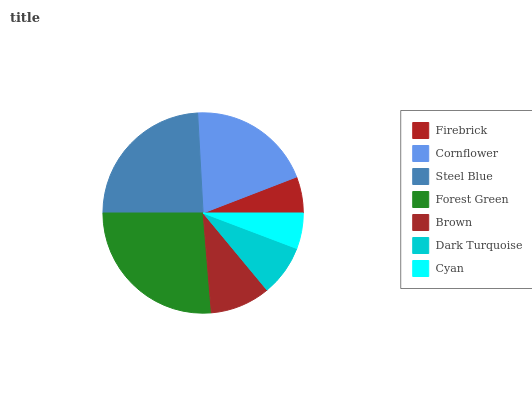Is Cyan the minimum?
Answer yes or no. Yes. Is Forest Green the maximum?
Answer yes or no. Yes. Is Cornflower the minimum?
Answer yes or no. No. Is Cornflower the maximum?
Answer yes or no. No. Is Cornflower greater than Firebrick?
Answer yes or no. Yes. Is Firebrick less than Cornflower?
Answer yes or no. Yes. Is Firebrick greater than Cornflower?
Answer yes or no. No. Is Cornflower less than Firebrick?
Answer yes or no. No. Is Brown the high median?
Answer yes or no. Yes. Is Brown the low median?
Answer yes or no. Yes. Is Forest Green the high median?
Answer yes or no. No. Is Forest Green the low median?
Answer yes or no. No. 